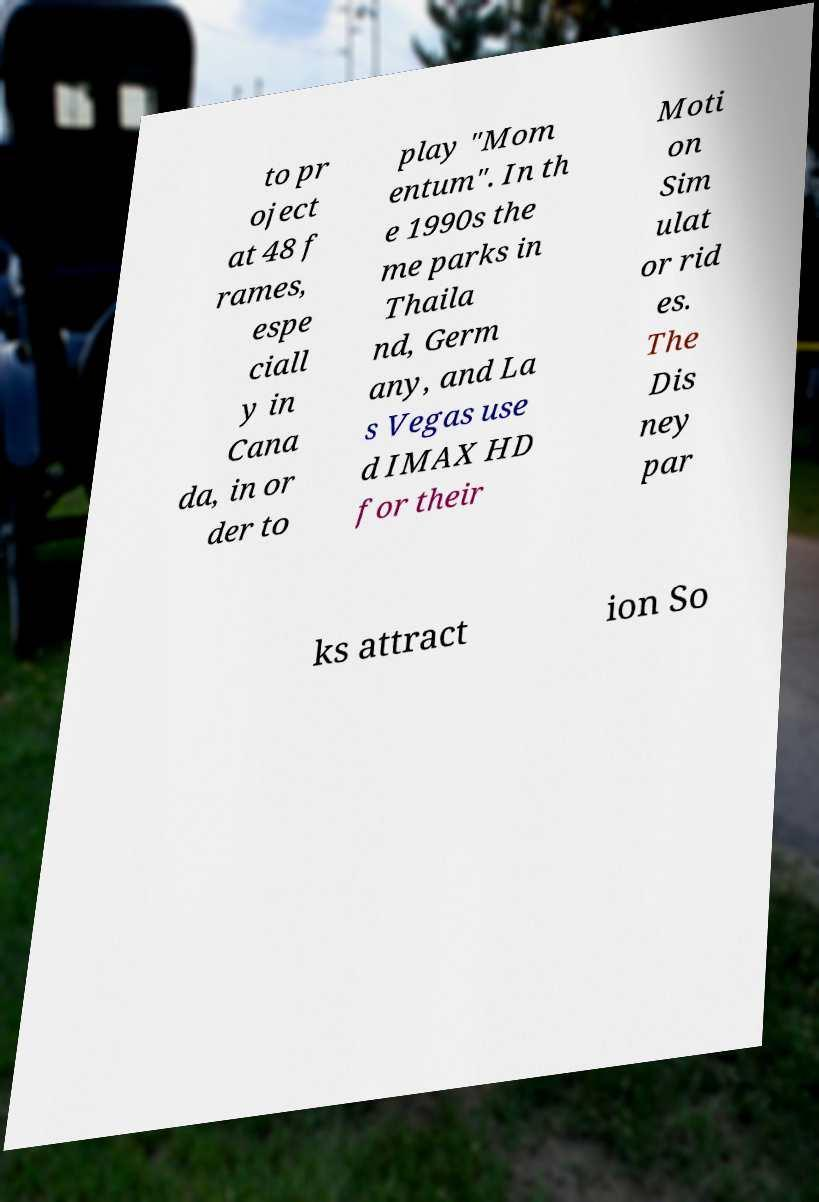Can you accurately transcribe the text from the provided image for me? to pr oject at 48 f rames, espe ciall y in Cana da, in or der to play "Mom entum". In th e 1990s the me parks in Thaila nd, Germ any, and La s Vegas use d IMAX HD for their Moti on Sim ulat or rid es. The Dis ney par ks attract ion So 